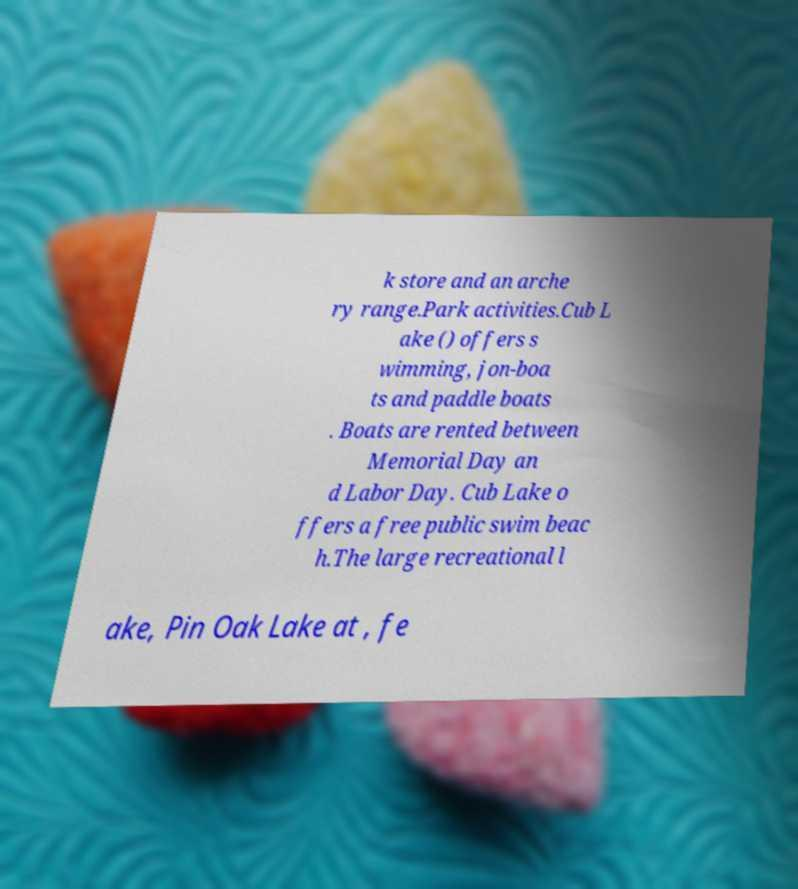Could you assist in decoding the text presented in this image and type it out clearly? k store and an arche ry range.Park activities.Cub L ake () offers s wimming, jon-boa ts and paddle boats . Boats are rented between Memorial Day an d Labor Day. Cub Lake o ffers a free public swim beac h.The large recreational l ake, Pin Oak Lake at , fe 